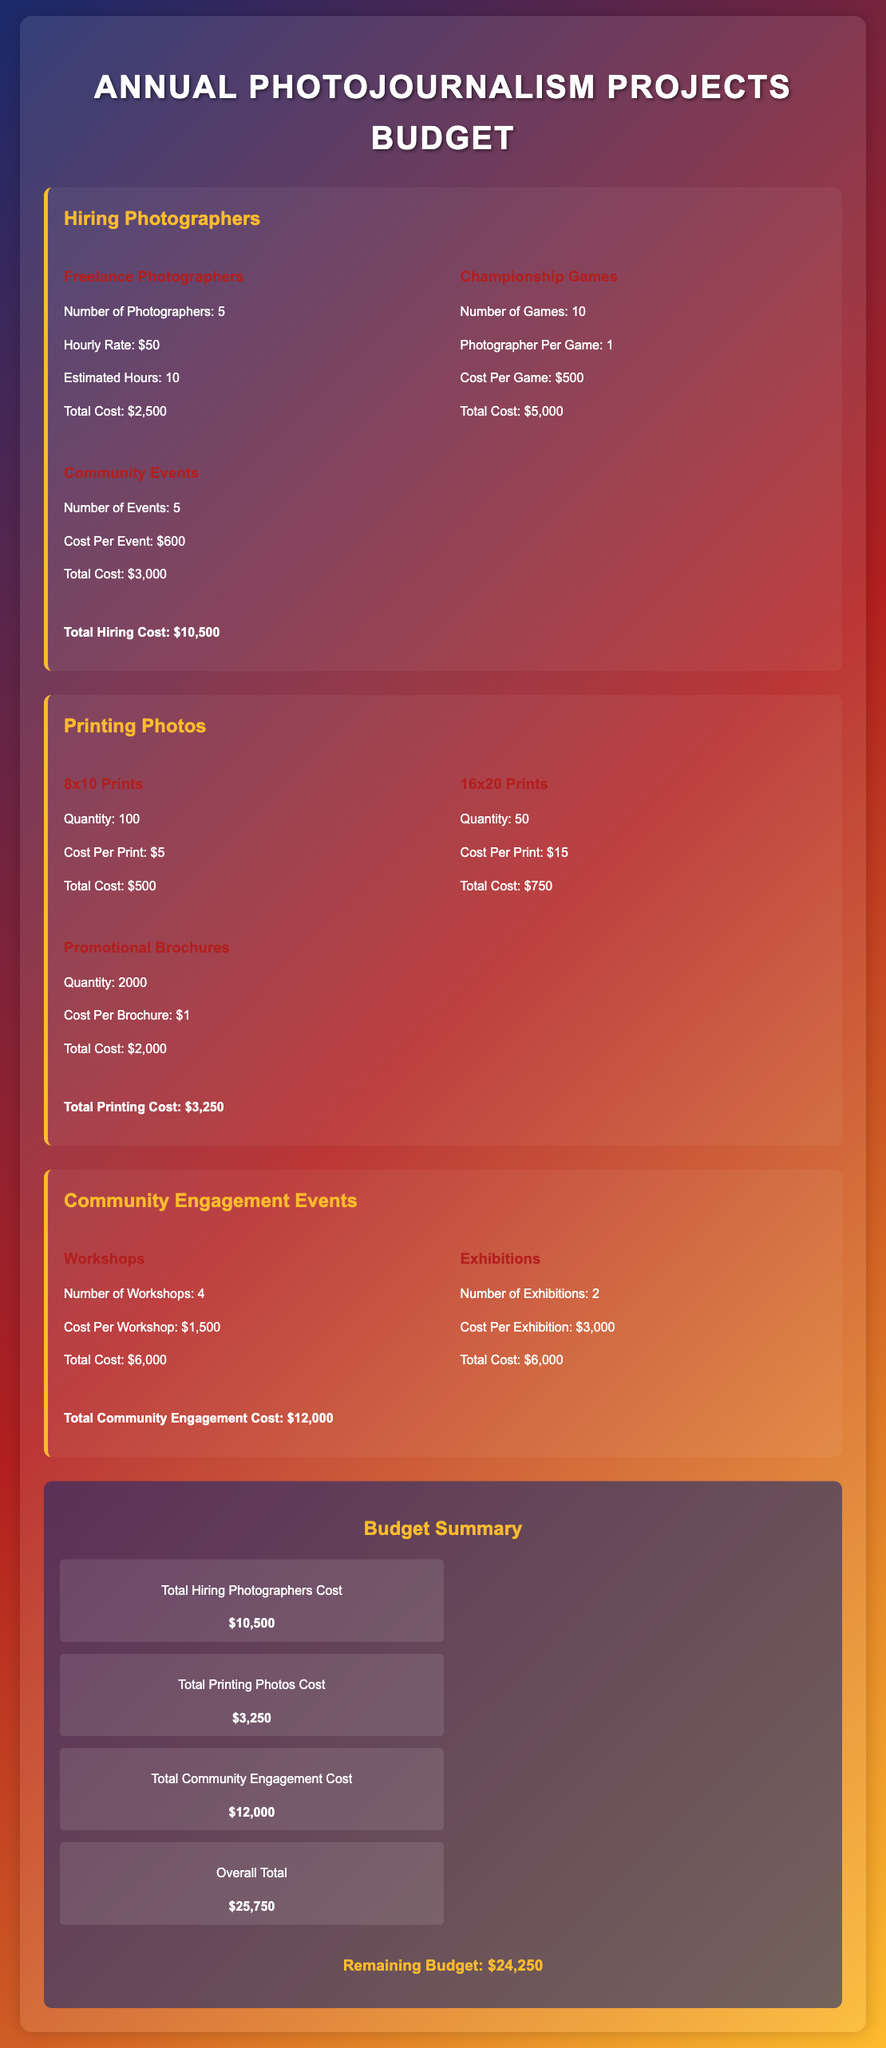What is the total cost for hiring photographers? The total cost for hiring photographers includes freelance photographers, championship games, and community events, which sums up to $10,500.
Answer: $10,500 How many workshops are planned? The document states that there are 4 workshops planned for community engagement.
Answer: 4 What is the cost per event for community events? The document mentions that the cost per event for community events is $600.
Answer: $600 What is the quantity of 16x20 prints? The document specifies that 50 units of 16x20 prints will be produced.
Answer: 50 What is the total printing cost? The total printing cost is calculated from 8x10 prints, 16x20 prints, and promotional brochures, summing up to $3,250.
Answer: $3,250 How many exhibitions will be held? According to the document, there will be 2 exhibitions held as part of the community engagement events.
Answer: 2 What is the cost per brochure? The document indicates that the cost per brochure is $1.
Answer: $1 What is the total community engagement cost? The total community engagement cost includes workshops and exhibitions, amounting to $12,000.
Answer: $12,000 What is the overall total budget? The overall total budget is the sum of all costs listed, equating to $25,750.
Answer: $25,750 